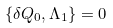Convert formula to latex. <formula><loc_0><loc_0><loc_500><loc_500>\left \{ \delta Q _ { 0 } , \Lambda _ { 1 } \right \} = 0</formula> 